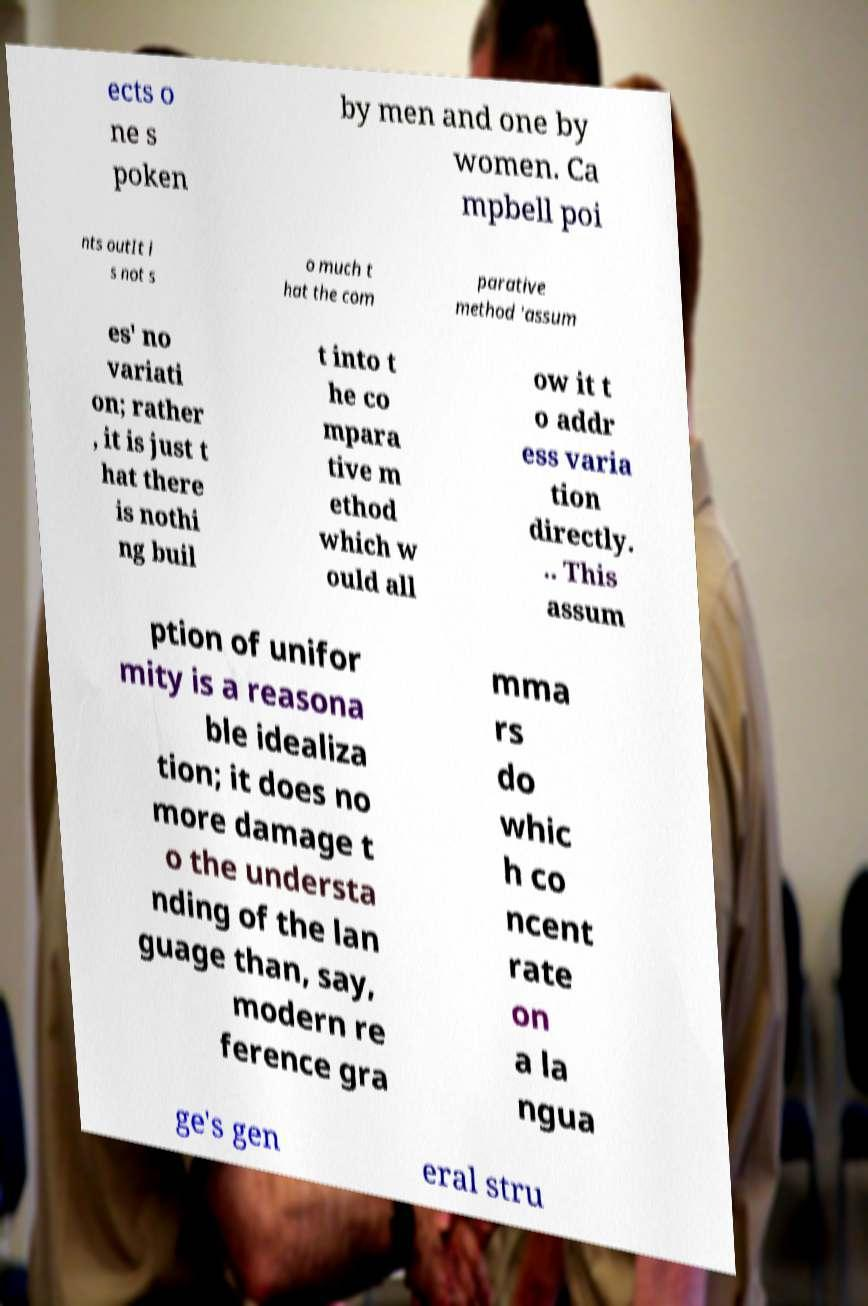I need the written content from this picture converted into text. Can you do that? ects o ne s poken by men and one by women. Ca mpbell poi nts outIt i s not s o much t hat the com parative method 'assum es' no variati on; rather , it is just t hat there is nothi ng buil t into t he co mpara tive m ethod which w ould all ow it t o addr ess varia tion directly. .. This assum ption of unifor mity is a reasona ble idealiza tion; it does no more damage t o the understa nding of the lan guage than, say, modern re ference gra mma rs do whic h co ncent rate on a la ngua ge's gen eral stru 